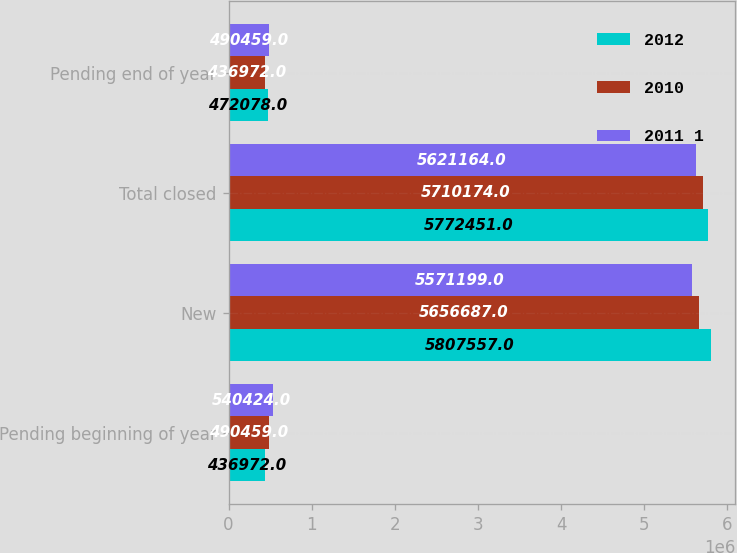Convert chart. <chart><loc_0><loc_0><loc_500><loc_500><stacked_bar_chart><ecel><fcel>Pending beginning of year<fcel>New<fcel>Total closed<fcel>Pending end of year<nl><fcel>2012<fcel>436972<fcel>5.80756e+06<fcel>5.77245e+06<fcel>472078<nl><fcel>2010<fcel>490459<fcel>5.65669e+06<fcel>5.71017e+06<fcel>436972<nl><fcel>2011 1<fcel>540424<fcel>5.5712e+06<fcel>5.62116e+06<fcel>490459<nl></chart> 